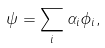Convert formula to latex. <formula><loc_0><loc_0><loc_500><loc_500>\psi = \sum _ { i } \alpha _ { i } \phi _ { i } ,</formula> 